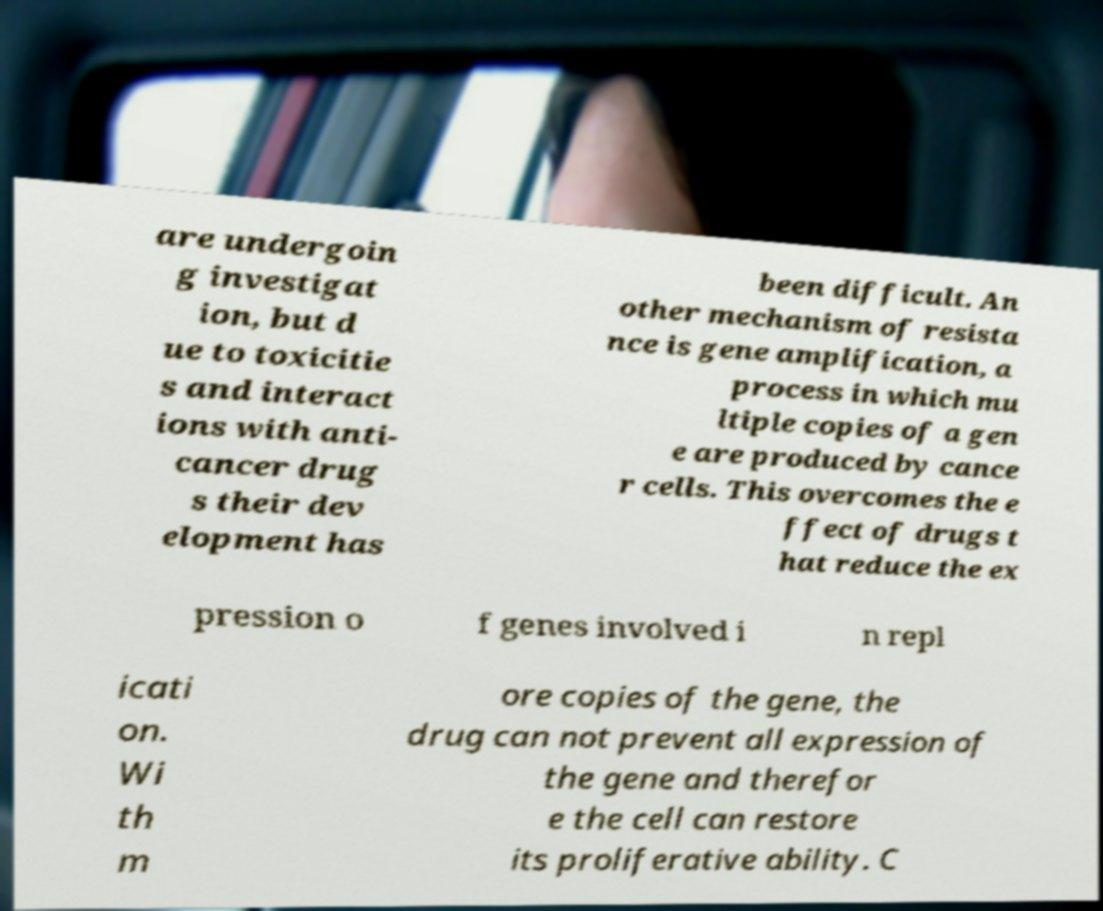I need the written content from this picture converted into text. Can you do that? are undergoin g investigat ion, but d ue to toxicitie s and interact ions with anti- cancer drug s their dev elopment has been difficult. An other mechanism of resista nce is gene amplification, a process in which mu ltiple copies of a gen e are produced by cance r cells. This overcomes the e ffect of drugs t hat reduce the ex pression o f genes involved i n repl icati on. Wi th m ore copies of the gene, the drug can not prevent all expression of the gene and therefor e the cell can restore its proliferative ability. C 